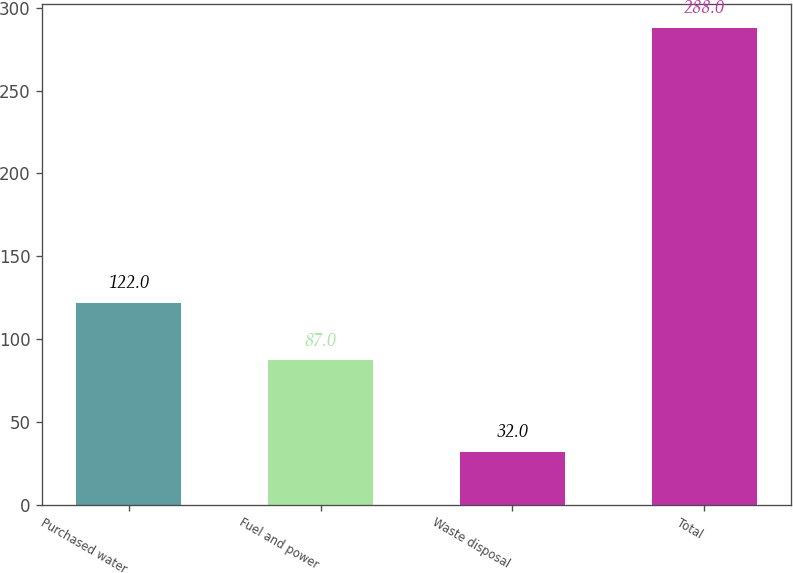<chart> <loc_0><loc_0><loc_500><loc_500><bar_chart><fcel>Purchased water<fcel>Fuel and power<fcel>Waste disposal<fcel>Total<nl><fcel>122<fcel>87<fcel>32<fcel>288<nl></chart> 